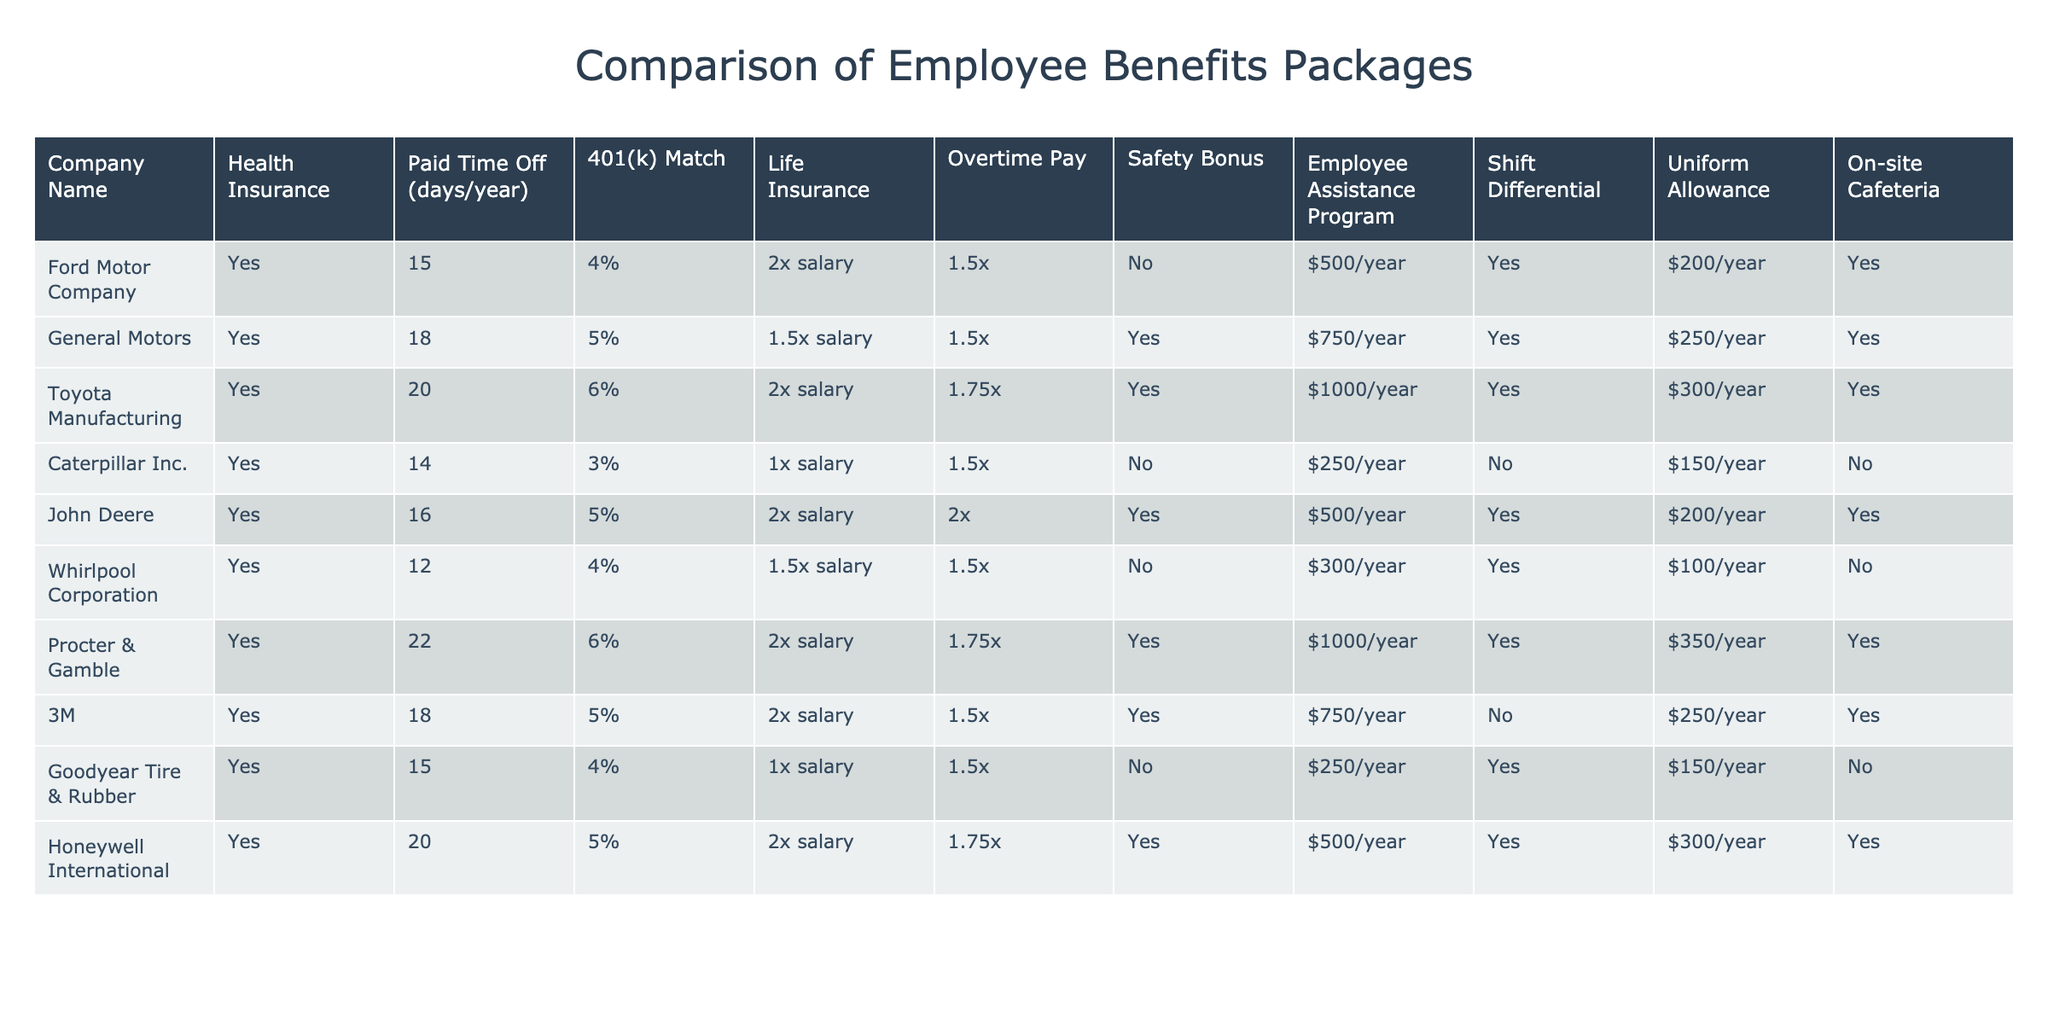What is the maximum Paid Time Off offered by any company? Looking through the Paid Time Off column, the highest value is 22 days, which is provided by Procter & Gamble.
Answer: 22 Which companies offer a Safety Bonus? By checking the Safety Bonus column, we see that General Motors, John Deere, and Honeywell International offer a Safety Bonus (marked as "Yes").
Answer: General Motors, John Deere, Honeywell International What is the average 401(k) match percentage among the companies listed? To find the average, we sum the 401(k) match percentages: 4 + 5 + 6 + 3 + 5 + 4 + 6 + 5 + 4 + 5 = 57. There are 10 companies, so the average is 57 / 10 = 5.7%.
Answer: 5.7% Does Caterpillar Inc. offer an on-site cafeteria? Looking at the On-site Cafeteria column, Caterpillar Inc. is marked as "No," indicating they do not offer an on-site cafeteria.
Answer: No Which company has the highest uniform allowance, and what is the amount? Checking the Uniform Allowance column, Toyota Manufacturing has the highest allowance at $300 per year.
Answer: Toyota Manufacturing, $300 If a worker at Whirlpool Corporation works overtime, how much additional pay do they get compared to their regular pay? Whirlpool Corporation offers 1.5 times salary for overtime pay. This means if they make $1000 regular pay, they would make $1500 during overtime.
Answer: 1.5 times their regular pay Is there a company that offers Life Insurance at 3 times the salary? Reviewing the Life Insurance column, no company offers a Life Insurance amount of 3 times the salary; the maximum is 2 times the salary provided by Caterpillar Inc., Toyota Manufacturing, Ford Motor Company, and John Deere.
Answer: No Which company has the least Paid Time Off, and how many days is it? The least Paid Time Off in the table is 12 days, which belongs to Whirlpool Corporation.
Answer: Whirlpool Corporation, 12 days What is the total amount of Employee Assistance Program funds provided by companies that offer it? The companies offering this benefit are General Motors, Toyota Manufacturing, Procter & Gamble, 3M, and Honeywell International. Summing their values gives $750 + $1000 + $1000 + $750 + $500 = $4000.
Answer: $4000 